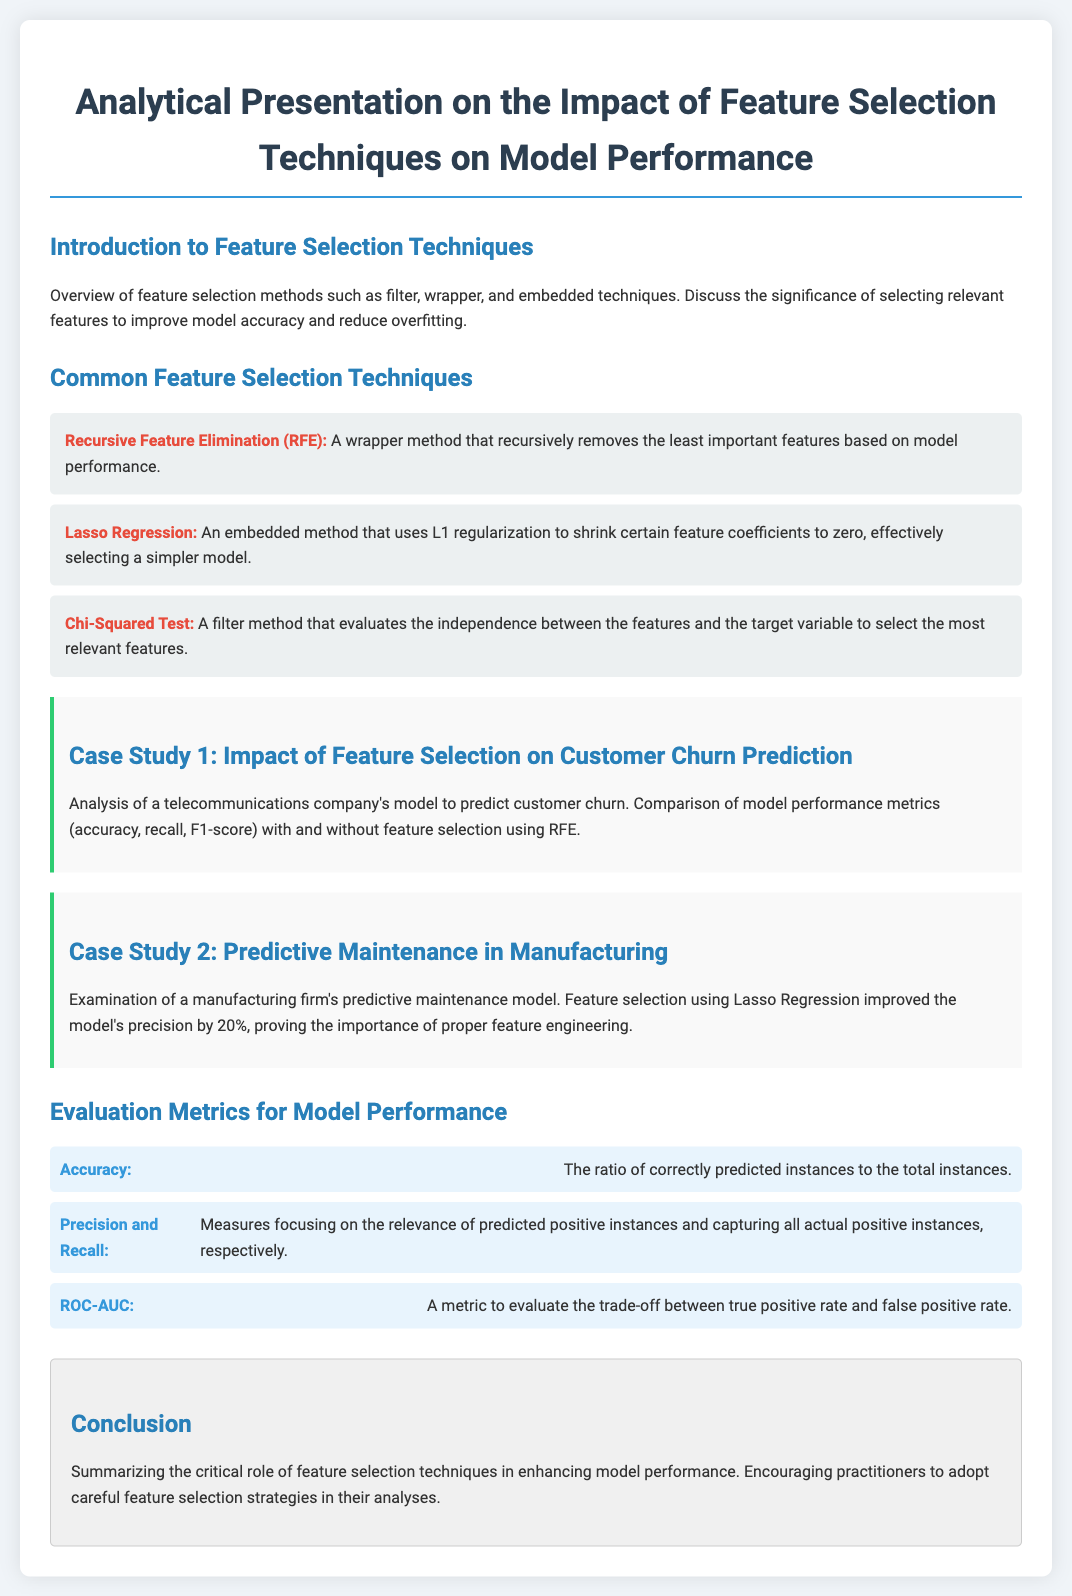What are the three types of feature selection techniques mentioned? The document lists filter, wrapper, and embedded techniques as the three types of feature selection methods.
Answer: filter, wrapper, embedded What does RFE stand for? The acronym RFE is used in the document to refer to Recursive Feature Elimination.
Answer: Recursive Feature Elimination Which case study demonstrates the use of Lasso Regression? The document specifies that the second case study focuses on a manufacturing firm's predictive maintenance model that used Lasso Regression.
Answer: Predictive Maintenance in Manufacturing What is one of the evaluation metrics mentioned for model performance? The document outlines several evaluation metrics, one of which is Accuracy.
Answer: Accuracy By what percentage did Lasso Regression improve model precision in the second case study? According to the document, Lasso Regression improved the model's precision by 20%.
Answer: 20% What conclusion is drawn regarding feature selection techniques? The document concludes that feature selection techniques are crucial in enhancing model performance.
Answer: Enhance model performance What does ROC-AUC evaluate? ROC-AUC is described in the document as a metric to evaluate the trade-off between true positive rate and false positive rate.
Answer: True positive rate and false positive rate 